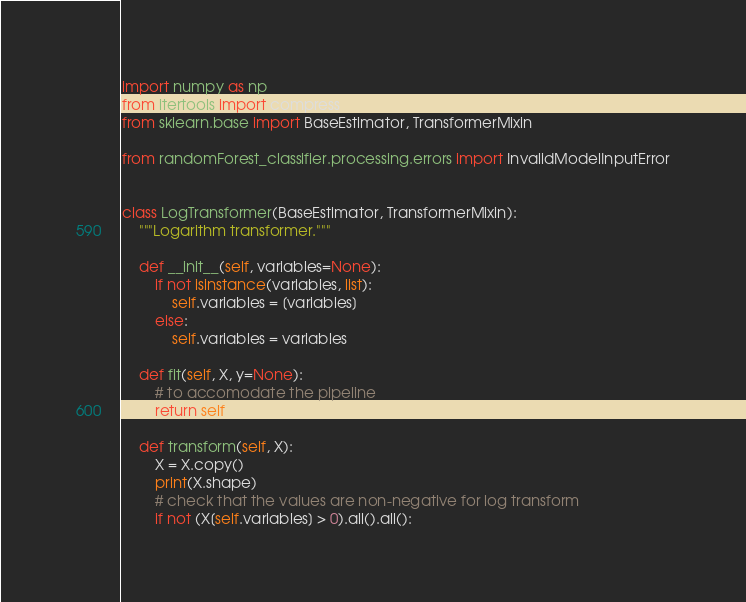Convert code to text. <code><loc_0><loc_0><loc_500><loc_500><_Python_>import numpy as np
from itertools import compress
from sklearn.base import BaseEstimator, TransformerMixin

from randomForest_classifier.processing.errors import InvalidModelInputError


class LogTransformer(BaseEstimator, TransformerMixin):
    """Logarithm transformer."""

    def __init__(self, variables=None):
        if not isinstance(variables, list):
            self.variables = [variables]
        else:
            self.variables = variables

    def fit(self, X, y=None):
        # to accomodate the pipeline
        return self

    def transform(self, X):
        X = X.copy()
        print(X.shape)
        # check that the values are non-negative for log transform
        if not (X[self.variables] > 0).all().all():</code> 